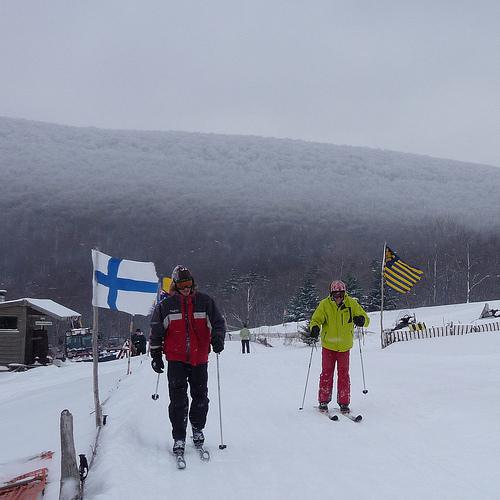Question: what are the people holding?
Choices:
A. Ski Poles.
B. Snowboards.
C. Surfboards.
D. Skateboards.
Answer with the letter. Answer: A Question: what are the people wearing on their feet?
Choices:
A. Boots.
B. Skis.
C. Shoes.
D. Sandals.
Answer with the letter. Answer: B Question: where are the people standing?
Choices:
A. On a hill.
B. On a porch.
C. On a ski slope.
D. On the grass.
Answer with the letter. Answer: C Question: what is in the background?
Choices:
A. Hill.
B. Forest.
C. Field.
D. A mountain.
Answer with the letter. Answer: D Question: what is the sky conditions?
Choices:
A. Foggy.
B. Misty.
C. Cloudy.
D. Hazy.
Answer with the letter. Answer: D Question: how many people are posing for this photo?
Choices:
A. Three.
B. One.
C. Two.
D. Four.
Answer with the letter. Answer: C 